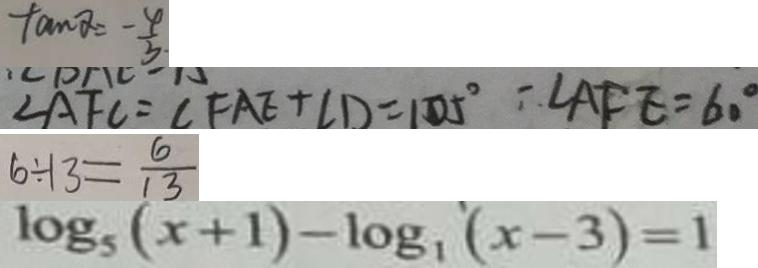Convert formula to latex. <formula><loc_0><loc_0><loc_500><loc_500>\tan \alpha = - \frac { 4 } { 3 } 
 \angle A F C = \angle F A E + \angle D = 1 0 5 ^ { \circ } - \angle A F E = 6 0 ^ { \circ } 
 6 \div 1 3 = \frac { 6 } { 1 3 } 
 \log _ { 5 } ( x + 1 ) - \log _ { 1 } ^ { \prime } ( x - 3 ) = 1</formula> 